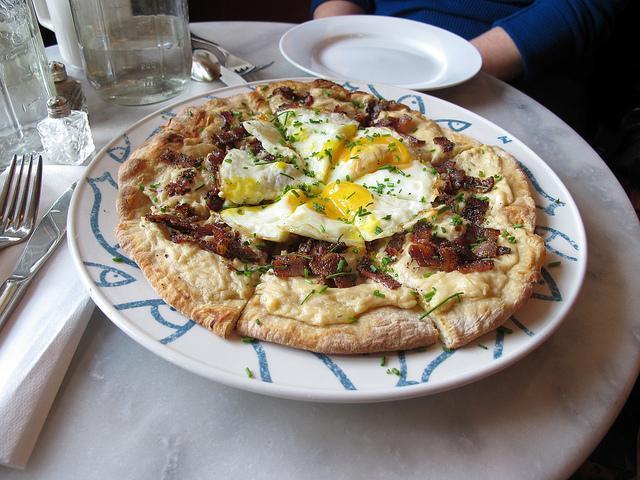Does the caption "The person is touching the pizza." correctly depict the image?
Answer yes or no. No. 